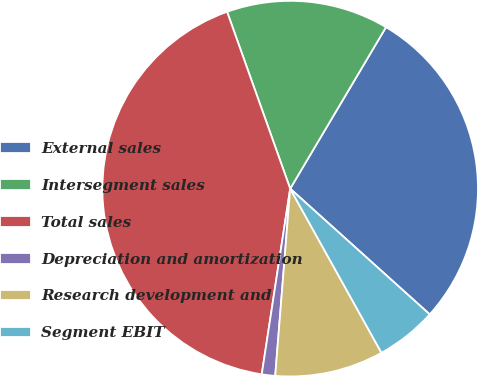<chart> <loc_0><loc_0><loc_500><loc_500><pie_chart><fcel>External sales<fcel>Intersegment sales<fcel>Total sales<fcel>Depreciation and amortization<fcel>Research development and<fcel>Segment EBIT<nl><fcel>28.15%<fcel>13.98%<fcel>42.13%<fcel>1.15%<fcel>9.35%<fcel>5.25%<nl></chart> 